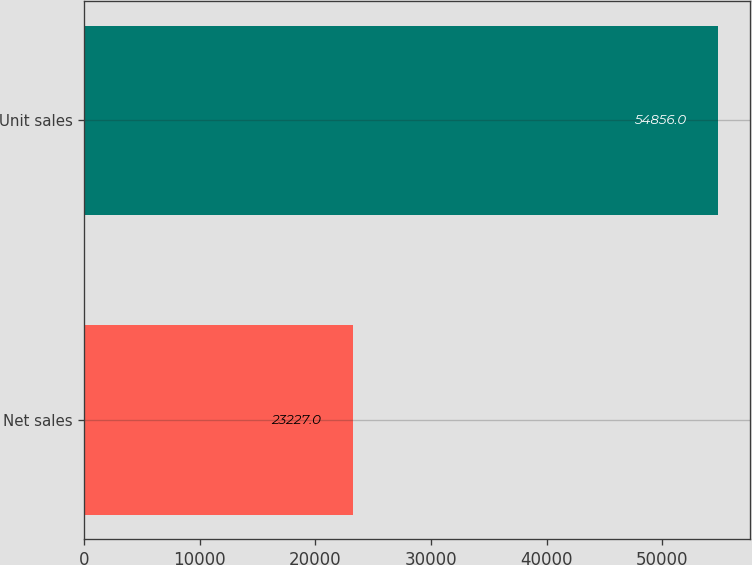Convert chart to OTSL. <chart><loc_0><loc_0><loc_500><loc_500><bar_chart><fcel>Net sales<fcel>Unit sales<nl><fcel>23227<fcel>54856<nl></chart> 